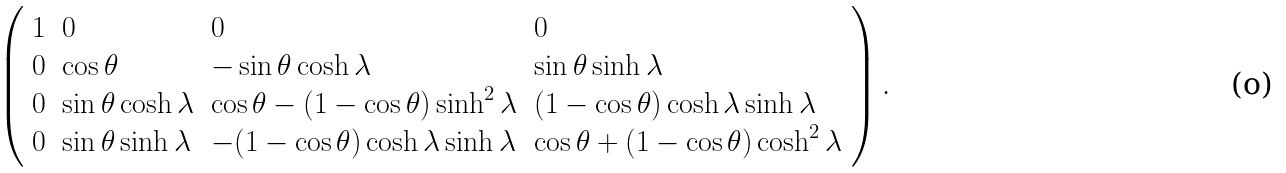Convert formula to latex. <formula><loc_0><loc_0><loc_500><loc_500>\left ( \begin{array} { l l l l } { 1 } & { 0 } & { 0 } & { 0 } \\ { 0 } & { \cos \theta } & { - \sin \theta \cosh \lambda } & { \sin \theta \sinh \lambda } \\ { 0 } & { \sin \theta \cosh \lambda } & { { \cos \theta - ( 1 - \cos \theta ) \sinh ^ { 2 } \lambda } } & { ( 1 - \cos \theta ) \cosh \lambda \sinh \lambda } \\ { 0 } & { \sin \theta \sinh \lambda } & { - ( 1 - \cos \theta ) \cosh \lambda \sinh \lambda } & { { \cos \theta + ( 1 - \cos \theta ) \cosh ^ { 2 } \lambda } } \end{array} \right ) .</formula> 